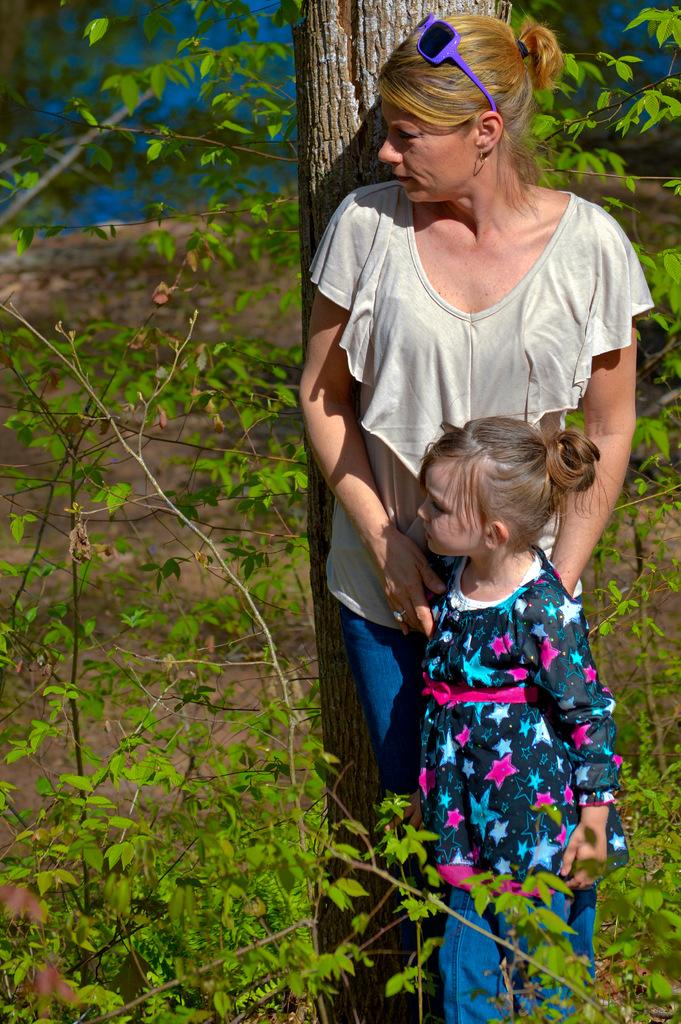What is the lady wearing in the image? The lady is wearing glasses in the image. Who else is present in the image besides the lady? There is a kid in the image. What can be seen in the background of the image? There are plants and a tree trunk visible in the background of the image. What type of bread is being used to build the structure in the image? There is no bread or structure present in the image. 